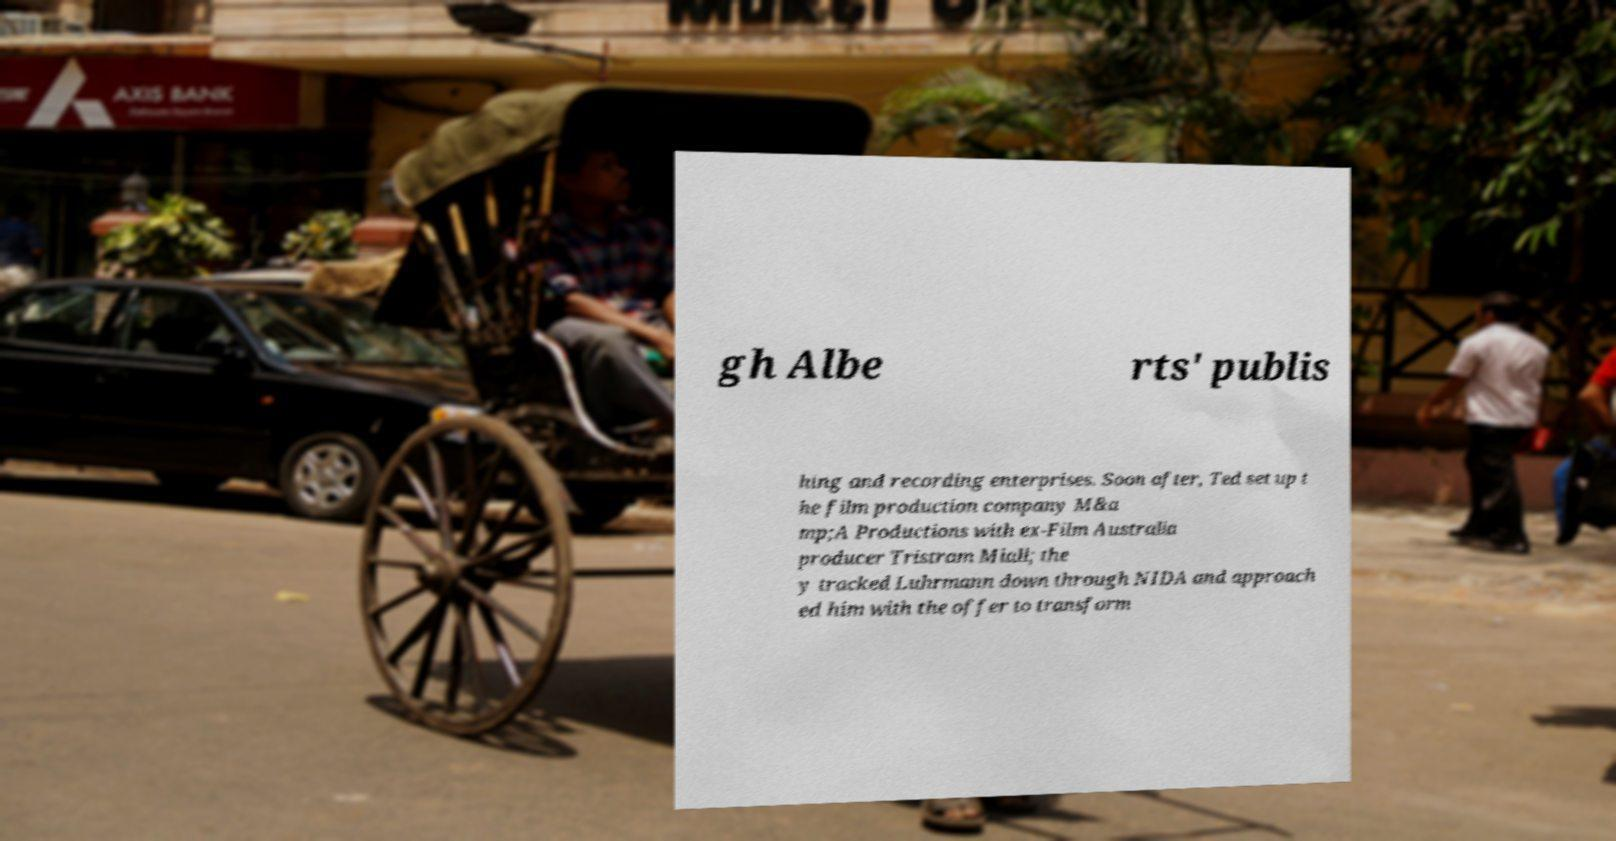Can you read and provide the text displayed in the image?This photo seems to have some interesting text. Can you extract and type it out for me? gh Albe rts' publis hing and recording enterprises. Soon after, Ted set up t he film production company M&a mp;A Productions with ex-Film Australia producer Tristram Miall; the y tracked Luhrmann down through NIDA and approach ed him with the offer to transform 